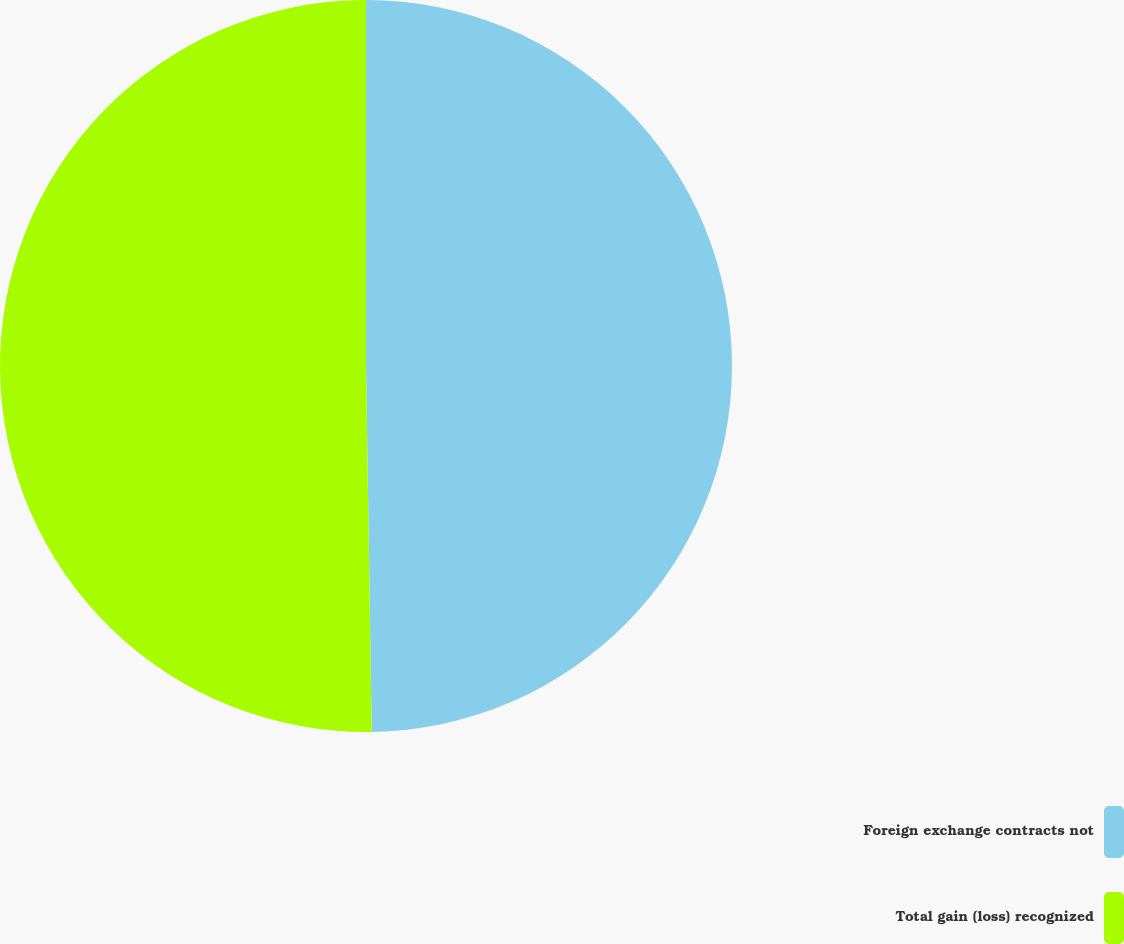<chart> <loc_0><loc_0><loc_500><loc_500><pie_chart><fcel>Foreign exchange contracts not<fcel>Total gain (loss) recognized<nl><fcel>49.75%<fcel>50.25%<nl></chart> 